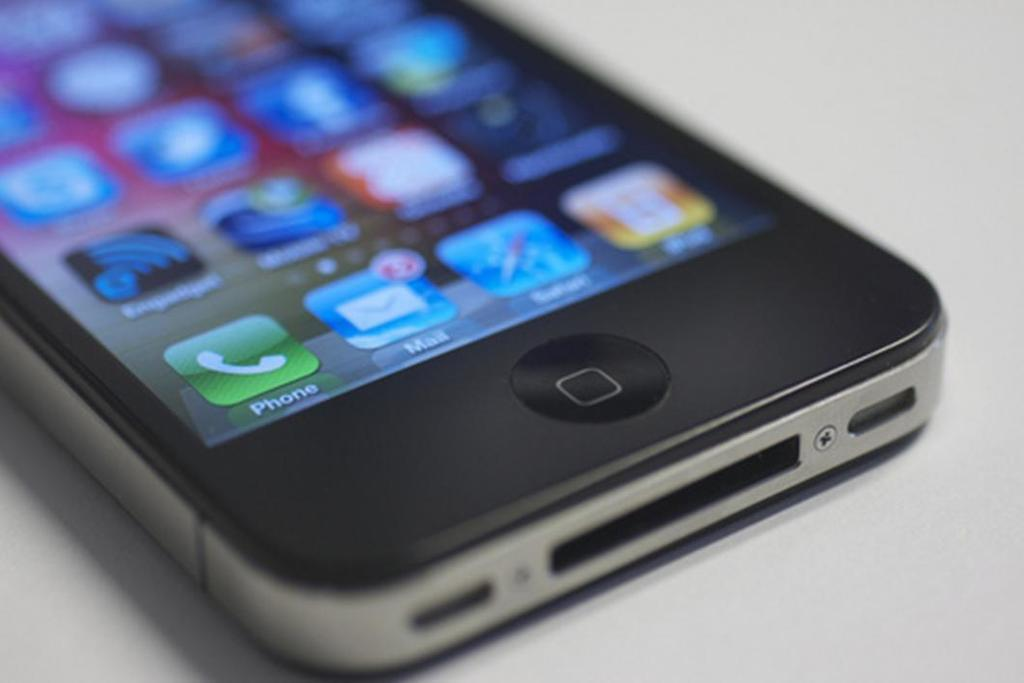<image>
Provide a brief description of the given image. Two icons on the screen of a cell phone offer a way to connect to mail accounts and to the phone. 